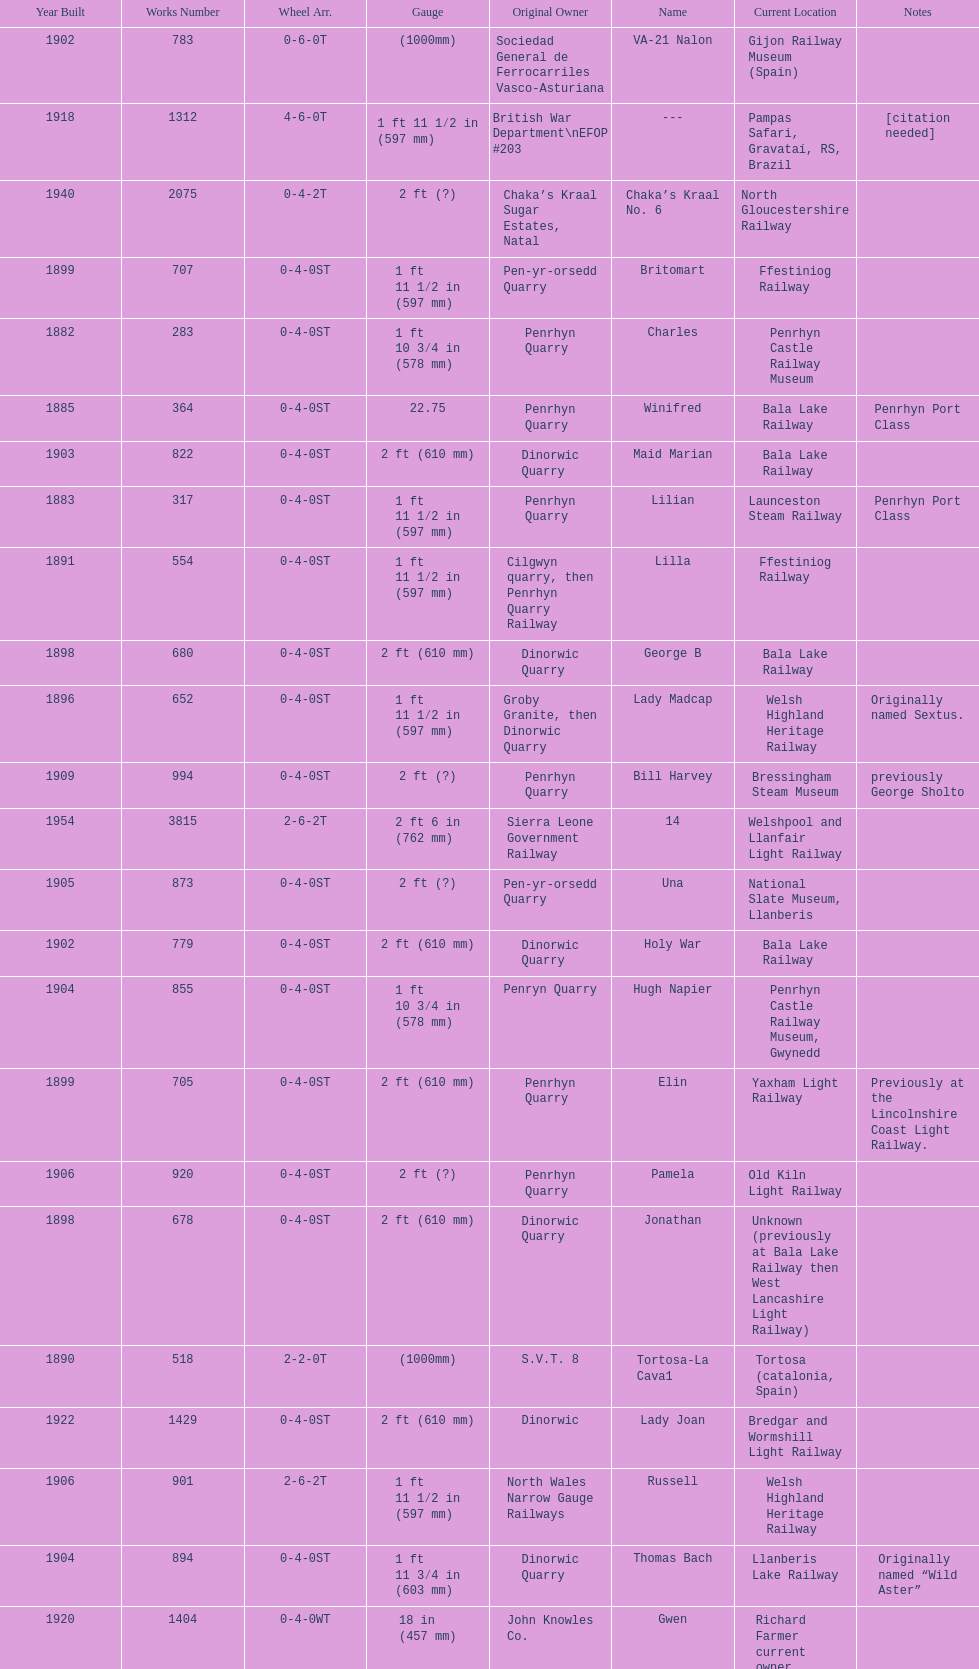What is the difference in gauge between works numbers 541 and 542? 32 mm. 